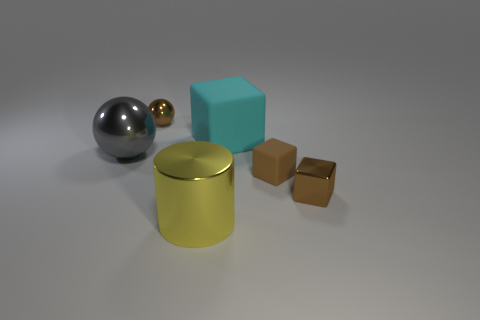What number of big cylinders are right of the cyan matte cube?
Make the answer very short. 0. There is a rubber block that is on the left side of the tiny brown block that is to the left of the small brown shiny cube; what is its color?
Provide a succinct answer. Cyan. Is there anything else that is the same shape as the big yellow shiny object?
Provide a succinct answer. No. Are there the same number of big matte blocks in front of the yellow object and large cyan rubber things that are to the right of the tiny rubber block?
Make the answer very short. Yes. How many spheres are gray things or tiny brown things?
Ensure brevity in your answer.  2. How many other objects are there of the same material as the cyan block?
Your answer should be very brief. 1. What shape is the tiny shiny thing that is behind the tiny matte thing?
Your response must be concise. Sphere. What material is the large yellow cylinder in front of the ball behind the big gray object?
Provide a short and direct response. Metal. Are there more small brown metallic objects in front of the small sphere than red matte balls?
Give a very brief answer. Yes. How many other things are there of the same color as the large rubber block?
Give a very brief answer. 0. 